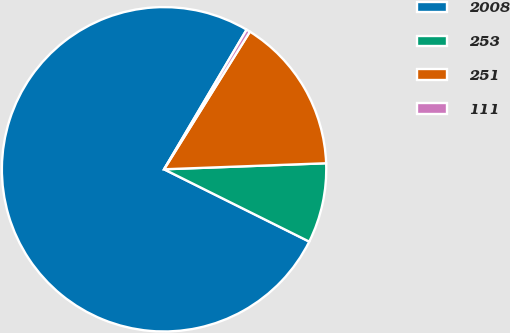Convert chart. <chart><loc_0><loc_0><loc_500><loc_500><pie_chart><fcel>2008<fcel>253<fcel>251<fcel>111<nl><fcel>76.14%<fcel>7.95%<fcel>15.53%<fcel>0.38%<nl></chart> 